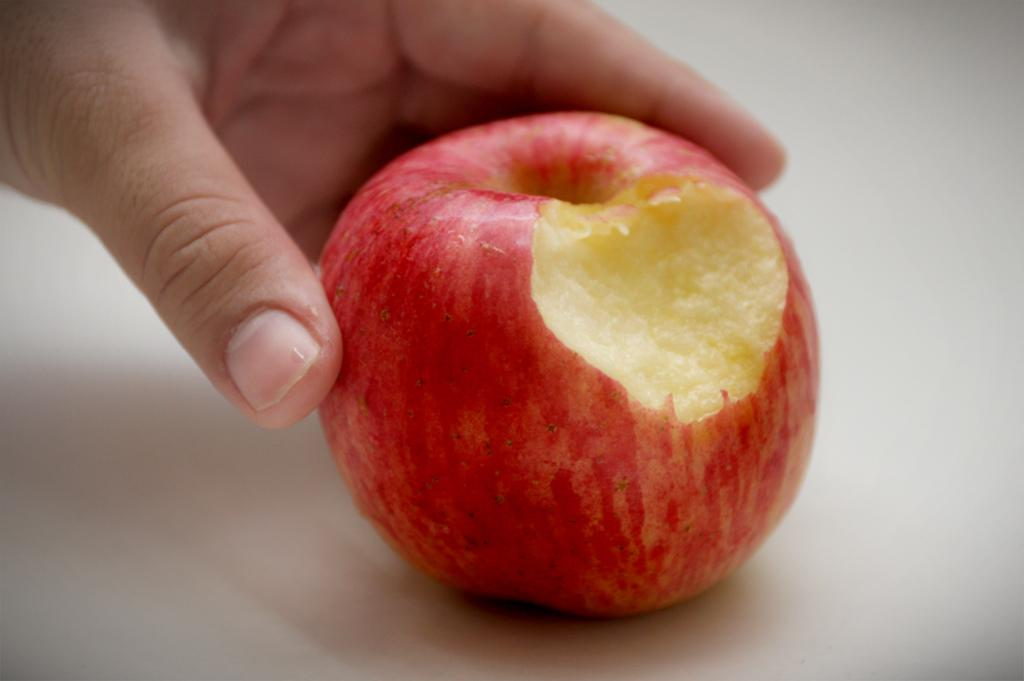What can be seen in the image related to a person's hand? There is a person's hand in the image. What is the hand holding? The hand is holding an apple. Can you describe the appearance of the apple? The apple is red and cream in color. What is the background or surface on which the apple is placed? The apple is on a white surface. What type of engine can be seen powering the apple in the image? There is no engine present in the image, and the apple is not being powered by any machinery. 